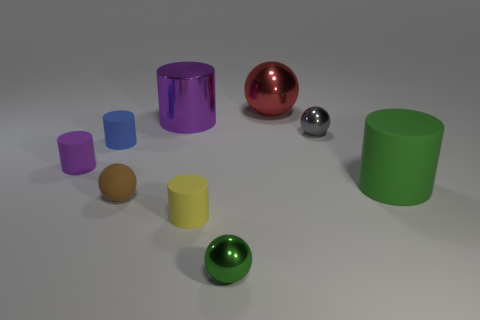There is a blue matte cylinder that is left of the gray shiny sphere; is it the same size as the metal object that is to the right of the big red sphere?
Provide a short and direct response. Yes. What number of other objects are there of the same material as the tiny green ball?
Offer a very short reply. 3. How many matte objects are either brown things or big cylinders?
Your response must be concise. 2. Is the number of tiny cyan objects less than the number of metallic things?
Ensure brevity in your answer.  Yes. Does the green sphere have the same size as the matte cylinder that is in front of the green cylinder?
Give a very brief answer. Yes. Is there any other thing that is the same shape as the small yellow matte thing?
Give a very brief answer. Yes. The yellow cylinder is what size?
Your answer should be very brief. Small. Is the number of green metallic objects in front of the tiny brown object less than the number of small yellow blocks?
Give a very brief answer. No. Do the brown sphere and the purple rubber object have the same size?
Keep it short and to the point. Yes. Is there anything else that has the same size as the purple matte cylinder?
Make the answer very short. Yes. 